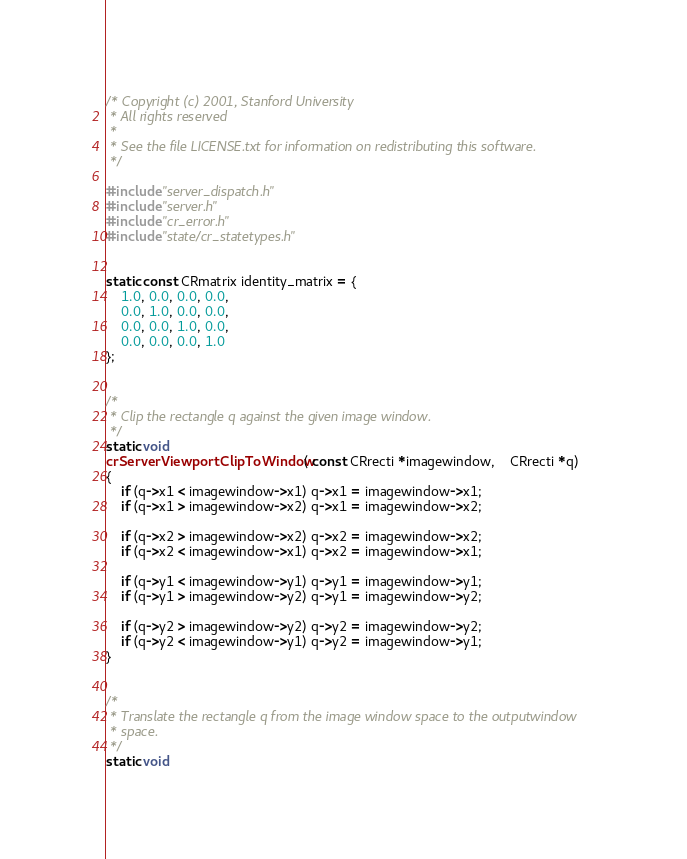Convert code to text. <code><loc_0><loc_0><loc_500><loc_500><_C_>/* Copyright (c) 2001, Stanford University
 * All rights reserved
 *
 * See the file LICENSE.txt for information on redistributing this software.
 */

#include "server_dispatch.h"
#include "server.h"
#include "cr_error.h"
#include "state/cr_statetypes.h"


static const CRmatrix identity_matrix = { 
	1.0, 0.0, 0.0, 0.0,
	0.0, 1.0, 0.0, 0.0,
	0.0, 0.0, 1.0, 0.0,
	0.0, 0.0, 0.0, 1.0
};


/*
 * Clip the rectangle q against the given image window.
 */
static void
crServerViewportClipToWindow( const CRrecti *imagewindow,	CRrecti *q) 
{
	if (q->x1 < imagewindow->x1) q->x1 = imagewindow->x1;
	if (q->x1 > imagewindow->x2) q->x1 = imagewindow->x2;

	if (q->x2 > imagewindow->x2) q->x2 = imagewindow->x2;
	if (q->x2 < imagewindow->x1) q->x2 = imagewindow->x1;
	
	if (q->y1 < imagewindow->y1) q->y1 = imagewindow->y1;
	if (q->y1 > imagewindow->y2) q->y1 = imagewindow->y2;

	if (q->y2 > imagewindow->y2) q->y2 = imagewindow->y2;
	if (q->y2 < imagewindow->y1) q->y2 = imagewindow->y1;
}


/*
 * Translate the rectangle q from the image window space to the outputwindow
 * space.
 */
static void</code> 